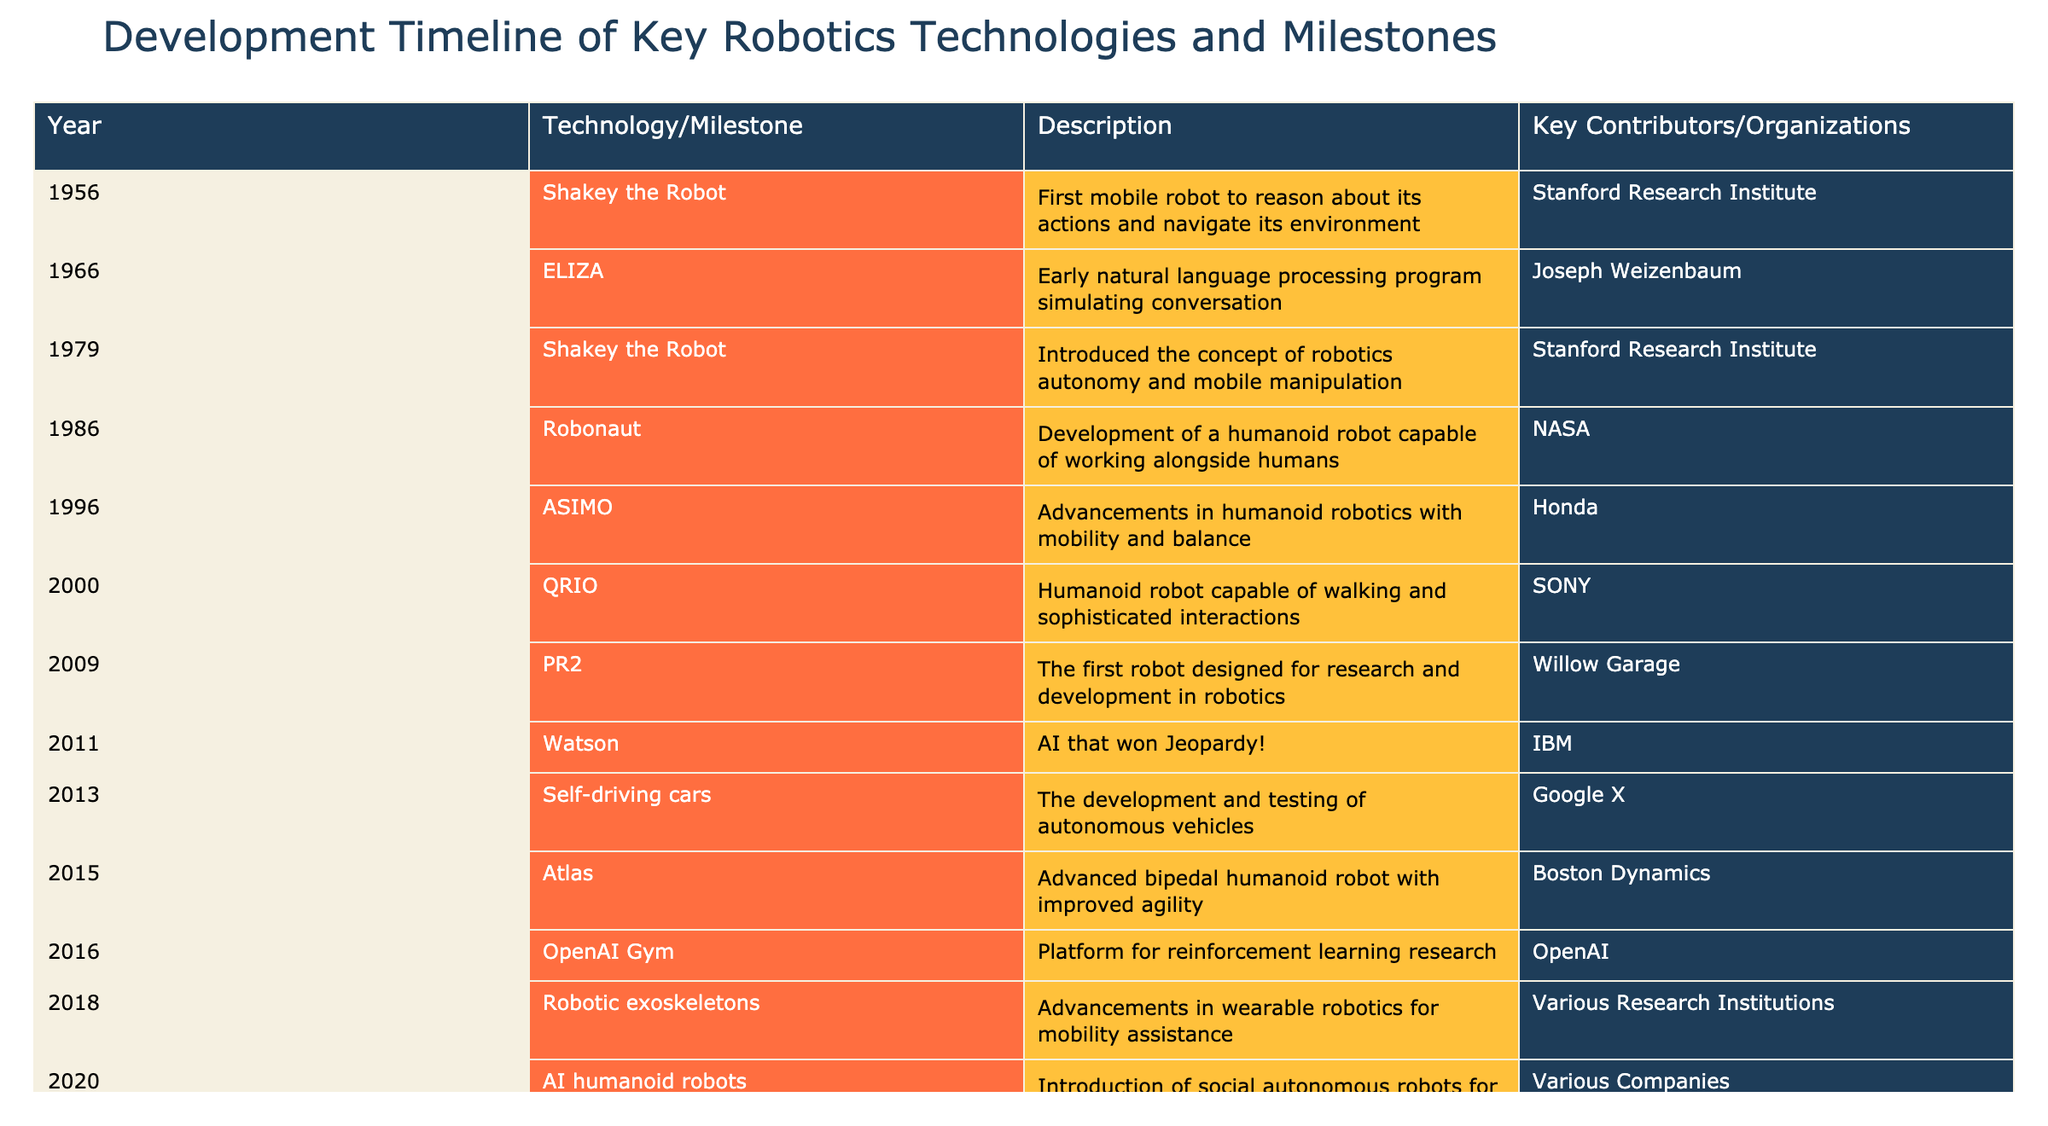What year was Shakey the Robot first introduced? Shakey the Robot was first introduced in 1956, according to the table.
Answer: 1956 Which organization contributed to the development of ASIMO? The organization that contributed to ASIMO is Honda, as stated in the table.
Answer: Honda How many technologies or milestones were developed after 2000? There are 6 milestones developed after the year 2000 (QRIO, PR2, Watson, Self-driving cars, Atlas, and AI humanoid robots) as we count each row accordingly.
Answer: 6 Was ELIZA the first natural language processing program? Yes, according to the description in the table, ELIZA was an early natural language processing program simulating conversation, indicating its pioneering role.
Answer: Yes What is the average year for the development milestones listed in the table? To find the average year, sum the years (1956 + 1966 + 1979 + 1986 + 1996 + 2000 + 2009 + 2011 + 2013 + 2015 + 2016 + 2018 + 2020 + 2021 + 2022 + 2023 =  2011.5) and divide by the total number of milestones (16). The average year is found to be approximately 2011.5.
Answer: 2011.5 Which technology had the earliest introduction and what was its significance? The earliest technology introduced was Shakey the Robot in 1956, which was significant for being the first mobile robot to reason about its actions and navigate its environment.
Answer: Shakey the Robot in 1956 How many key contributors or organizations are listed in the milestones after 2010? The organizations after 2010 are Google X, Boston Dynamics, Various Companies, Various Robotics Labs, Harvard Biodesign Lab, and Universal Robots, which totals to 6 contributors.
Answer: 6 Was there a notable change in technology focus from 2015 and onward? Yes, starting from 2015 with Atlas and onward, there is a clear shift towards collaborative robots (cobots), robotic exoskeletons, and AI humanoid robots indicating an increased focus on human interaction and assistance.
Answer: Yes In what year did the development of soft robotics take place? Soft robotics was developed in the year 2022, as indicated in the table.
Answer: 2022 